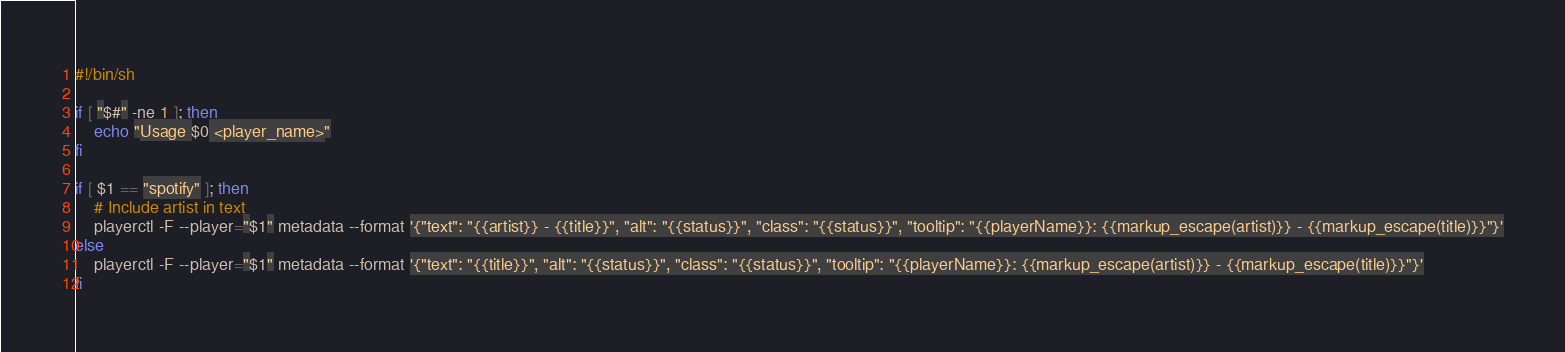Convert code to text. <code><loc_0><loc_0><loc_500><loc_500><_Bash_>#!/bin/sh

if [ "$#" -ne 1 ]; then
    echo "Usage $0 <player_name>"
fi

if [ $1 == "spotify" ]; then
    # Include artist in text
    playerctl -F --player="$1" metadata --format '{"text": "{{artist}} - {{title}}", "alt": "{{status}}", "class": "{{status}}", "tooltip": "{{playerName}}: {{markup_escape(artist)}} - {{markup_escape(title)}}"}'
else
    playerctl -F --player="$1" metadata --format '{"text": "{{title}}", "alt": "{{status}}", "class": "{{status}}", "tooltip": "{{playerName}}: {{markup_escape(artist)}} - {{markup_escape(title)}}"}'
fi
</code> 